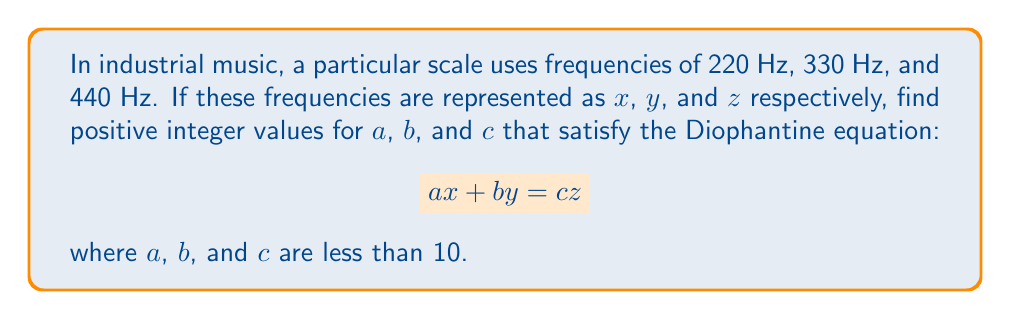What is the answer to this math problem? Let's approach this step-by-step:

1) First, substitute the given frequencies into the equation:
   $$ a(220) + b(330) = c(440) $$

2) Simplify by dividing all terms by 110:
   $$ 2a + 3b = 4c $$

3) We need to find positive integer values for $a$, $b$, and $c$ less than 10 that satisfy this equation.

4) Let's try some values:
   - If $a = 1$, then $2 + 3b = 4c$
   - If $b = 2$, then $2 + 6 = 4c$, so $c = 2$

5) Check if these values satisfy the original equation:
   $$ 1(220) + 2(330) = 2(440) $$
   $$ 220 + 660 = 880 $$
   $$ 880 = 880 $$

6) The equation is satisfied, and all values are positive integers less than 10.

Therefore, one solution is $a = 1$, $b = 2$, and $c = 2$.
Answer: $a = 1$, $b = 2$, $c = 2$ 